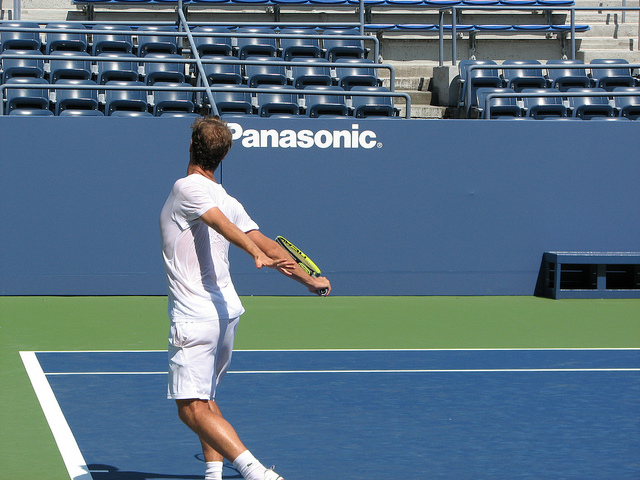Read and extract the text from this image. Panasonic 